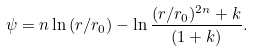Convert formula to latex. <formula><loc_0><loc_0><loc_500><loc_500>\psi = n \ln { ( r / r _ { 0 } ) } - \ln { \frac { ( r / r _ { 0 } ) ^ { 2 n } + k } { ( 1 + k ) } } .</formula> 